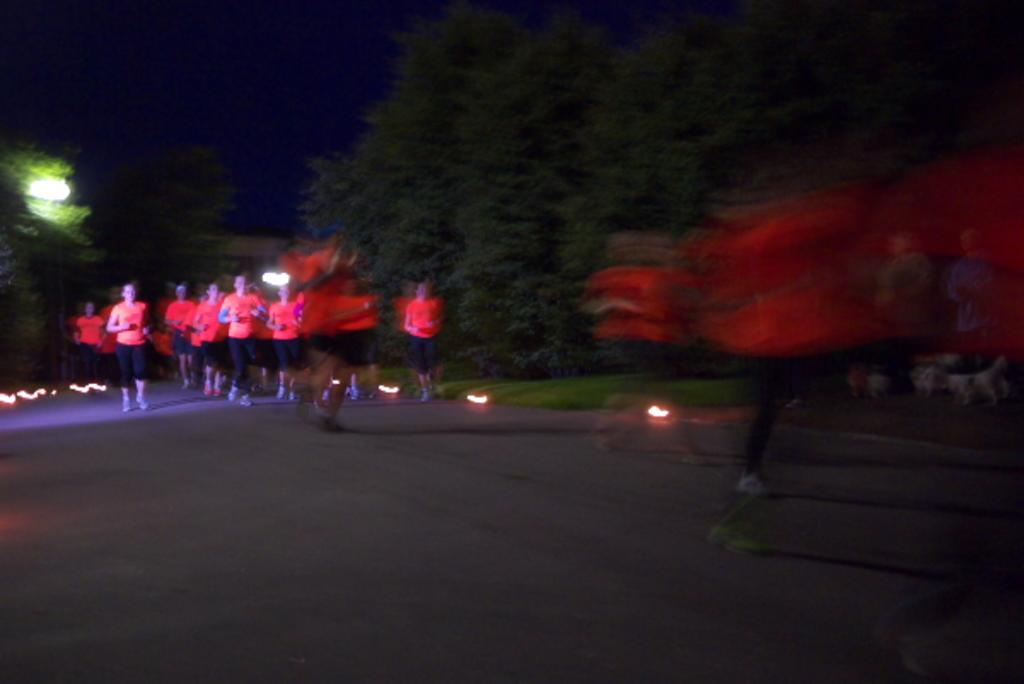What is happening in the image involving a group of people? The people in the image are running on the road. What can be seen in the image besides the people running? There are lights visible in the image, as well as trees and the sky in the background. What type of board is being used for the distribution of metal in the image? There is no board or metal distribution present in the image; it features a group of people running on the road. 